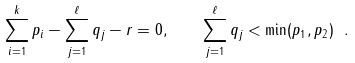<formula> <loc_0><loc_0><loc_500><loc_500>\sum _ { i = 1 } ^ { k } p _ { i } - \sum _ { j = 1 } ^ { \ell } q _ { j } - r = 0 , \quad \sum _ { j = 1 } ^ { \ell } q _ { j } < \min ( p _ { 1 } , p _ { 2 } ) \ .</formula> 